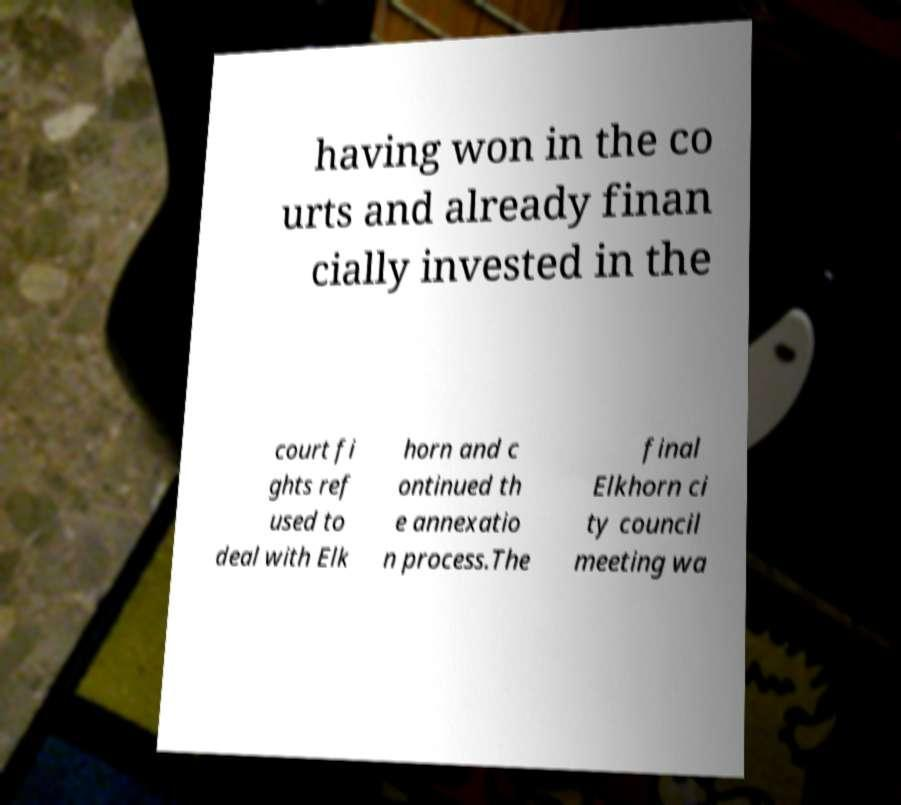For documentation purposes, I need the text within this image transcribed. Could you provide that? having won in the co urts and already finan cially invested in the court fi ghts ref used to deal with Elk horn and c ontinued th e annexatio n process.The final Elkhorn ci ty council meeting wa 